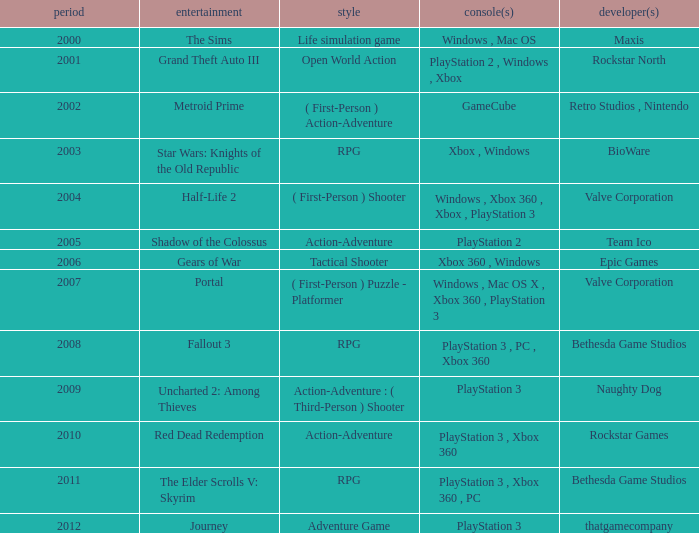What game was in 2001? Grand Theft Auto III. 